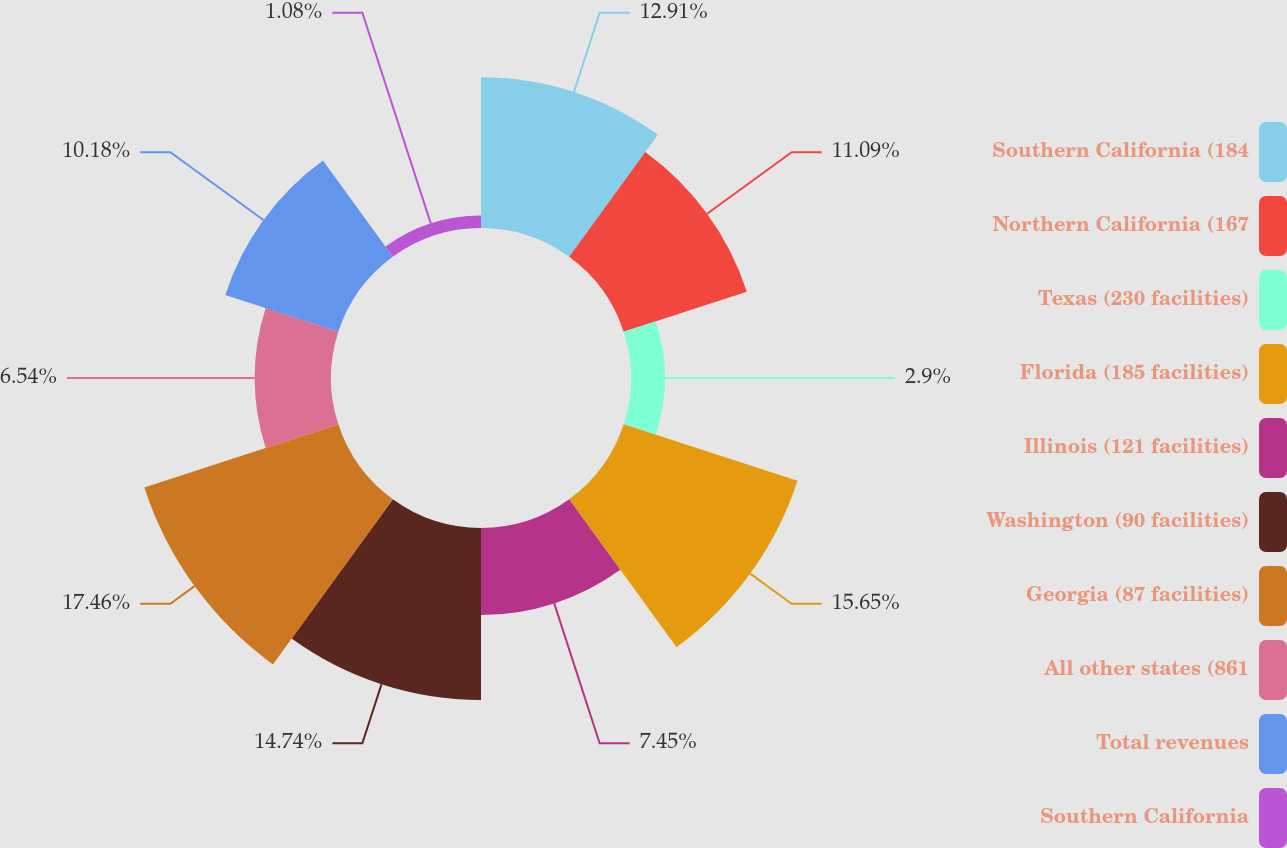Convert chart to OTSL. <chart><loc_0><loc_0><loc_500><loc_500><pie_chart><fcel>Southern California (184<fcel>Northern California (167<fcel>Texas (230 facilities)<fcel>Florida (185 facilities)<fcel>Illinois (121 facilities)<fcel>Washington (90 facilities)<fcel>Georgia (87 facilities)<fcel>All other states (861<fcel>Total revenues<fcel>Southern California<nl><fcel>12.91%<fcel>11.09%<fcel>2.9%<fcel>15.65%<fcel>7.45%<fcel>14.74%<fcel>17.47%<fcel>6.54%<fcel>10.18%<fcel>1.08%<nl></chart> 